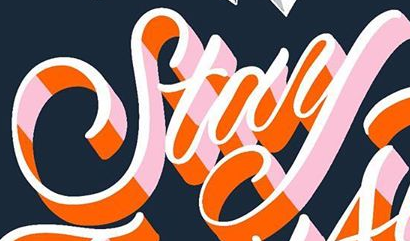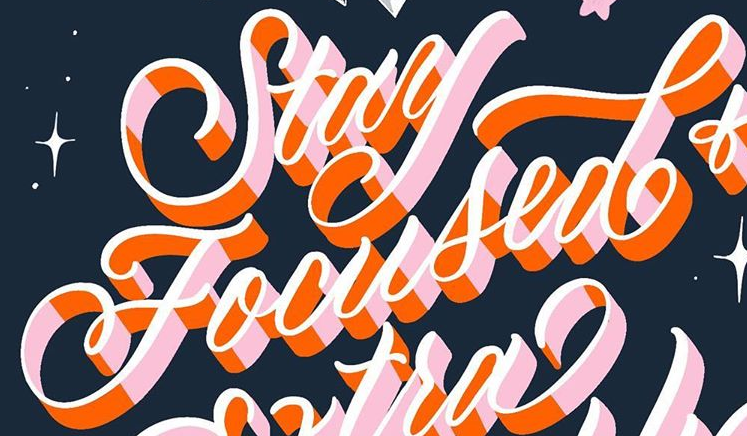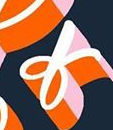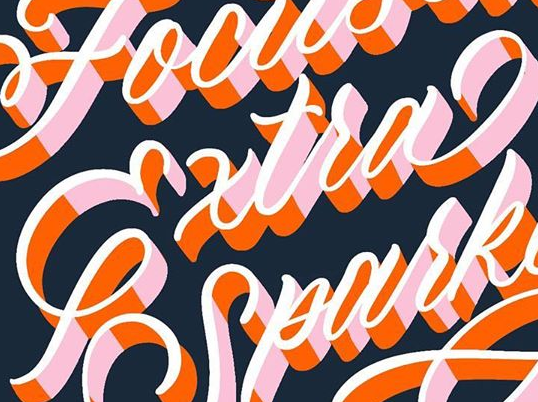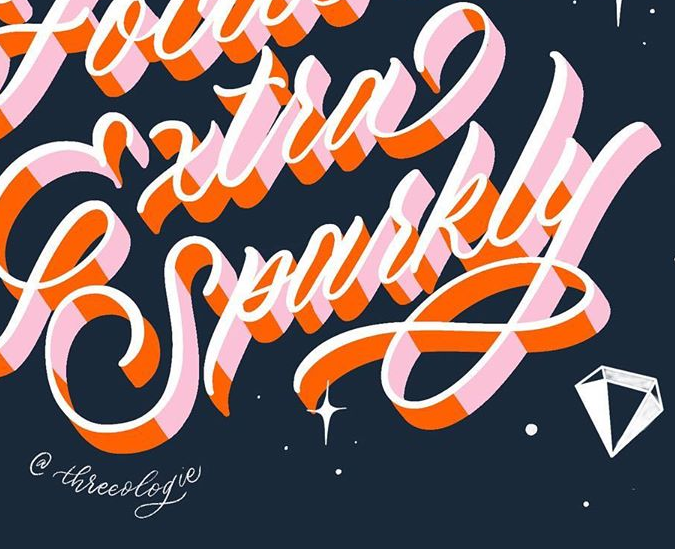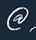Read the text from these images in sequence, separated by a semicolon. Stay; Focused; of; Extra; Sparkly; @ 